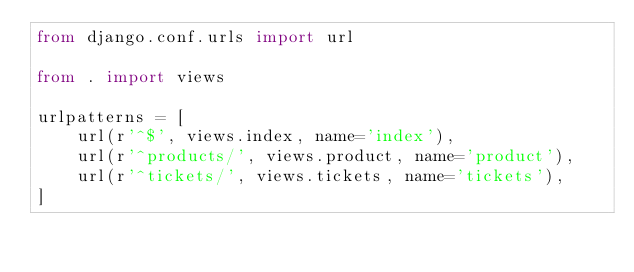<code> <loc_0><loc_0><loc_500><loc_500><_Python_>from django.conf.urls import url

from . import views

urlpatterns = [
    url(r'^$', views.index, name='index'),
    url(r'^products/', views.product, name='product'),
    url(r'^tickets/', views.tickets, name='tickets'),
]
</code> 